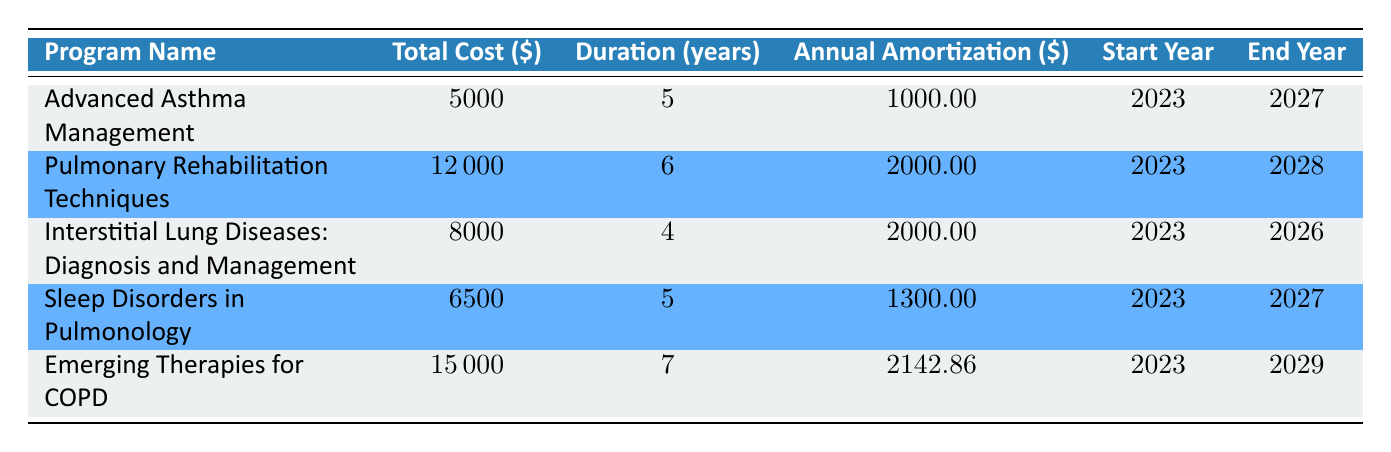What is the total cost of the "Pulmonary Rehabilitation Techniques" program? The total cost for "Pulmonary Rehabilitation Techniques" is explicitly stated in the table as 12000.
Answer: 12000 How many years does the "Interstitial Lung Diseases: Diagnosis and Management" program span? The duration of the program is provided in the table, specifically noted as 4 years.
Answer: 4 What is the annual amortization amount for the "Sleep Disorders in Pulmonology" program? The annual amortization for this program is listed in the table as 1300.00.
Answer: 1300.00 Which program has the highest annual amortization? By comparing the annual amortization values, "Emerging Therapies for COPD" has the highest amount at 2142.86, compared to the other programs listed.
Answer: Emerging Therapies for COPD Is the "Advanced Asthma Management" program less expensive than the "Sleep Disorders in Pulmonology" program? The costs are compared directly from the table—Advanced Asthma Management costs 5000 while Sleep Disorders costs 6500. Since 5000 is less than 6500, the statement is true.
Answer: Yes What is the total amortization amount for all programs listed? To find the total amortization amount, sum the individual annual amortization amounts: 1000 + 2000 + 2000 + 1300 + 2142.86 = 9642.86.
Answer: 9642.86 How many programs are scheduled to conclude in 2027? Reviewing the end year column, "Advanced Asthma Management" and "Sleep Disorders in Pulmonology" both end in 2027, making a total of 2 programs.
Answer: 2 Which program has an amortization period of exactly six years? By examining the duration column, the only program with a duration of six years is "Pulmonary Rehabilitation Techniques."
Answer: Pulmonary Rehabilitation Techniques If you wanted to amortize the total cost for "Emerging Therapies for COPD" over five years instead of seven, what would be the new annual amortization? The total cost for this program is 15000. Dividing this by the new duration (5 years) gives us an annual amortization of 3000.
Answer: 3000 